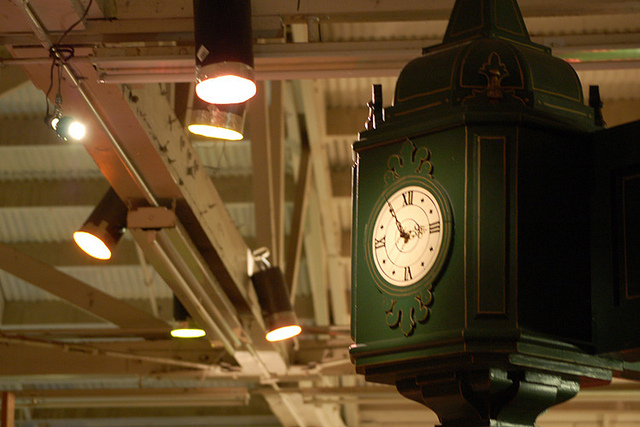Please transcribe the text in this image. XII III 